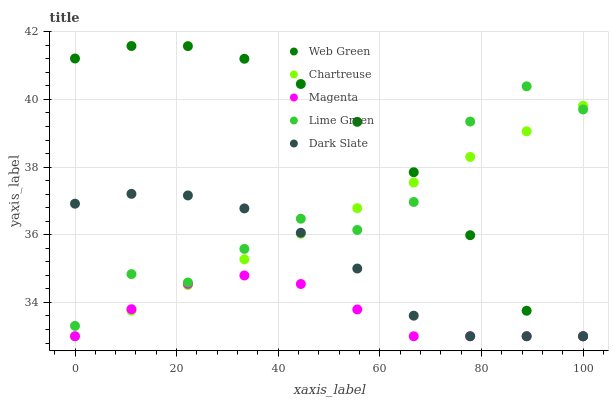Does Magenta have the minimum area under the curve?
Answer yes or no. Yes. Does Web Green have the maximum area under the curve?
Answer yes or no. Yes. Does Chartreuse have the minimum area under the curve?
Answer yes or no. No. Does Chartreuse have the maximum area under the curve?
Answer yes or no. No. Is Chartreuse the smoothest?
Answer yes or no. Yes. Is Lime Green the roughest?
Answer yes or no. Yes. Is Lime Green the smoothest?
Answer yes or no. No. Is Chartreuse the roughest?
Answer yes or no. No. Does Dark Slate have the lowest value?
Answer yes or no. Yes. Does Lime Green have the lowest value?
Answer yes or no. No. Does Web Green have the highest value?
Answer yes or no. Yes. Does Chartreuse have the highest value?
Answer yes or no. No. Is Magenta less than Lime Green?
Answer yes or no. Yes. Is Lime Green greater than Magenta?
Answer yes or no. Yes. Does Web Green intersect Lime Green?
Answer yes or no. Yes. Is Web Green less than Lime Green?
Answer yes or no. No. Is Web Green greater than Lime Green?
Answer yes or no. No. Does Magenta intersect Lime Green?
Answer yes or no. No. 